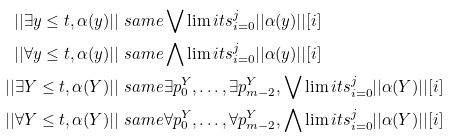<formula> <loc_0><loc_0><loc_500><loc_500>| | \exists y \leq t , \alpha ( y ) | | & \ s a m e \bigvee \lim i t s _ { i = 0 } ^ { j } | | \alpha ( y ) | | [ i ] \\ | | \forall y \leq t , \alpha ( y ) | | & \ s a m e \bigwedge \lim i t s _ { i = 0 } ^ { j } | | \alpha ( y ) | | [ i ] \\ | | \exists Y \leq t , \alpha ( Y ) | | & \ s a m e \exists p _ { 0 } ^ { Y } , \dots , \exists p _ { m - 2 } ^ { Y } , \bigvee \lim i t s _ { i = 0 } ^ { j } | | \alpha ( Y ) | | [ i ] \\ | | \forall Y \leq t , \alpha ( Y ) | | & \ s a m e \forall p _ { 0 } ^ { Y } , \dots , \forall p _ { m - 2 } ^ { Y } , \bigwedge \lim i t s _ { i = 0 } ^ { j } | | \alpha ( Y ) | | [ i ]</formula> 